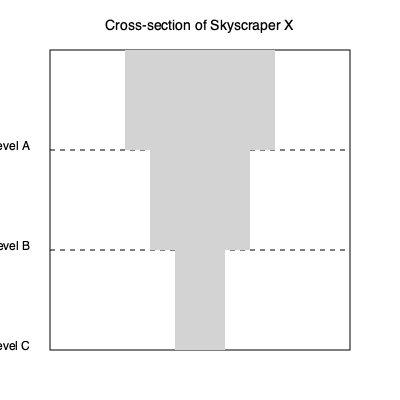Based on the cross-sectional drawing of Skyscraper X, what architectural principle is likely being employed to create its distinctive shape, and how does this principle contribute to the building's structural integrity and aesthetic appeal? To answer this question, let's analyze the cross-sectional drawing step-by-step:

1. Observe the shape: The building's cross-section narrows as it rises, creating a tapered profile.

2. Identify the architectural principle: This tapering design is known as "setback" architecture.

3. Understand the structural benefits:
   a) Reduced wind loads: The tapered shape decreases wind resistance at higher levels.
   b) Improved stability: A wider base provides better support and reduces sway.
   c) Efficient weight distribution: Less mass at the top reduces stress on the lower levels.

4. Consider the aesthetic appeal:
   a) Creates a distinctive silhouette in the skyline.
   b) Allows for terraces or sky gardens at setback levels.
   c) Provides visual interest through varying facade depths.

5. Historical context:
   The setback principle became popular in the early 20th century, partly due to zoning laws in cities like New York, which required buildings to allow more light to reach street level.

6. Modern applications:
   Contemporary skyscrapers often incorporate setbacks for both functional and aesthetic reasons, even when not required by zoning laws.

In conclusion, the setback principle employed in Skyscraper X enhances both its structural integrity through improved wind resistance and stability, while also creating an aesthetically pleasing and iconic form in the urban landscape.
Answer: Setback architecture 